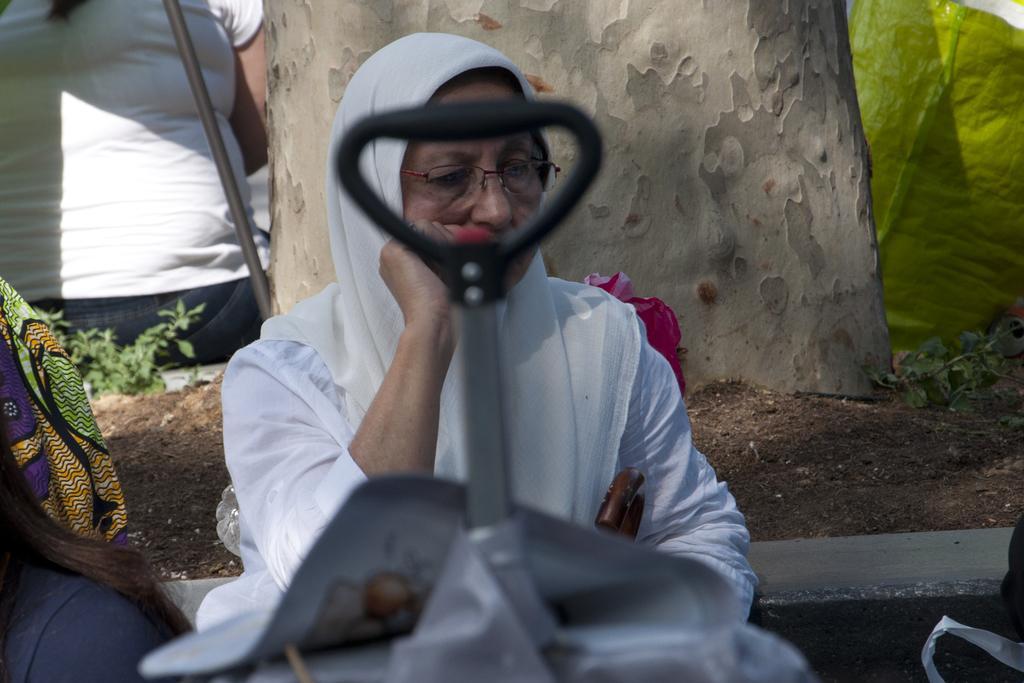In one or two sentences, can you explain what this image depicts? In this image we can see there is a luggage, behind that there is a woman sitting, beside the women there are a few people sitting around the tree and there are a few plants and luggages. 